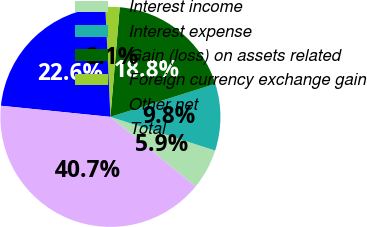<chart> <loc_0><loc_0><loc_500><loc_500><pie_chart><fcel>Interest income<fcel>Interest expense<fcel>Gain (loss) on assets related<fcel>Foreign currency exchange gain<fcel>Other net<fcel>Total<nl><fcel>5.95%<fcel>9.81%<fcel>18.79%<fcel>2.09%<fcel>22.65%<fcel>40.71%<nl></chart> 